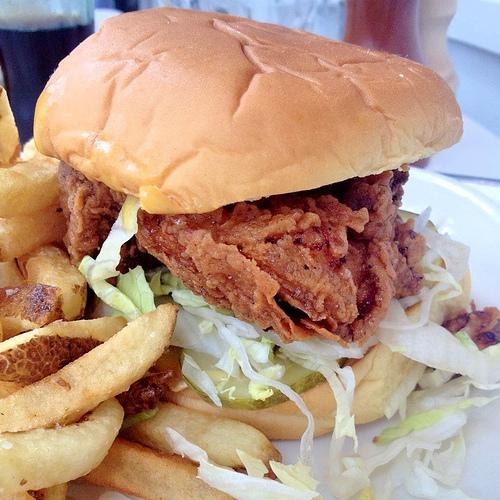Question: what color is the bun?
Choices:
A. White.
B. Red.
C. Yellow.
D. Brown.
Answer with the letter. Answer: D Question: what was the photo taken of?
Choices:
A. A torte.
B. A cookie.
C. A burger and fries.
D. A cake.
Answer with the letter. Answer: C Question: what are next to the burger?
Choices:
A. Broccoli.
B. French fries.
C. Onion rings.
D. Batterfried cheese curds.
Answer with the letter. Answer: B 